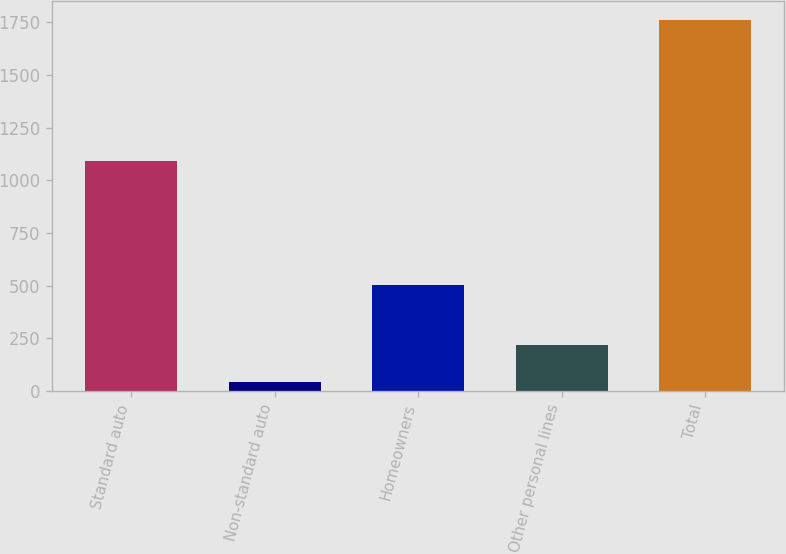Convert chart to OTSL. <chart><loc_0><loc_0><loc_500><loc_500><bar_chart><fcel>Standard auto<fcel>Non-standard auto<fcel>Homeowners<fcel>Other personal lines<fcel>Total<nl><fcel>1091<fcel>45<fcel>503<fcel>216.8<fcel>1763<nl></chart> 